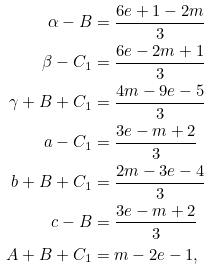<formula> <loc_0><loc_0><loc_500><loc_500>\alpha - B & = \frac { 6 e + 1 - 2 m } { 3 } \\ \beta - C _ { 1 } & = \frac { 6 e - 2 m + 1 } { 3 } \\ \gamma + B + C _ { 1 } & = \frac { 4 m - 9 e - 5 } { 3 } \\ a - C _ { 1 } & = \frac { 3 e - m + 2 } { 3 } \\ b + B + C _ { 1 } & = \frac { 2 m - 3 e - 4 } { 3 } \\ c - B & = \frac { 3 e - m + 2 } { 3 } \\ A + B + C _ { 1 } & = m - 2 e - 1 ,</formula> 